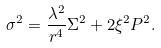Convert formula to latex. <formula><loc_0><loc_0><loc_500><loc_500>\sigma ^ { 2 } = \frac { \lambda ^ { 2 } } { r ^ { 4 } } \Sigma ^ { 2 } + 2 \xi ^ { 2 } P ^ { 2 } .</formula> 